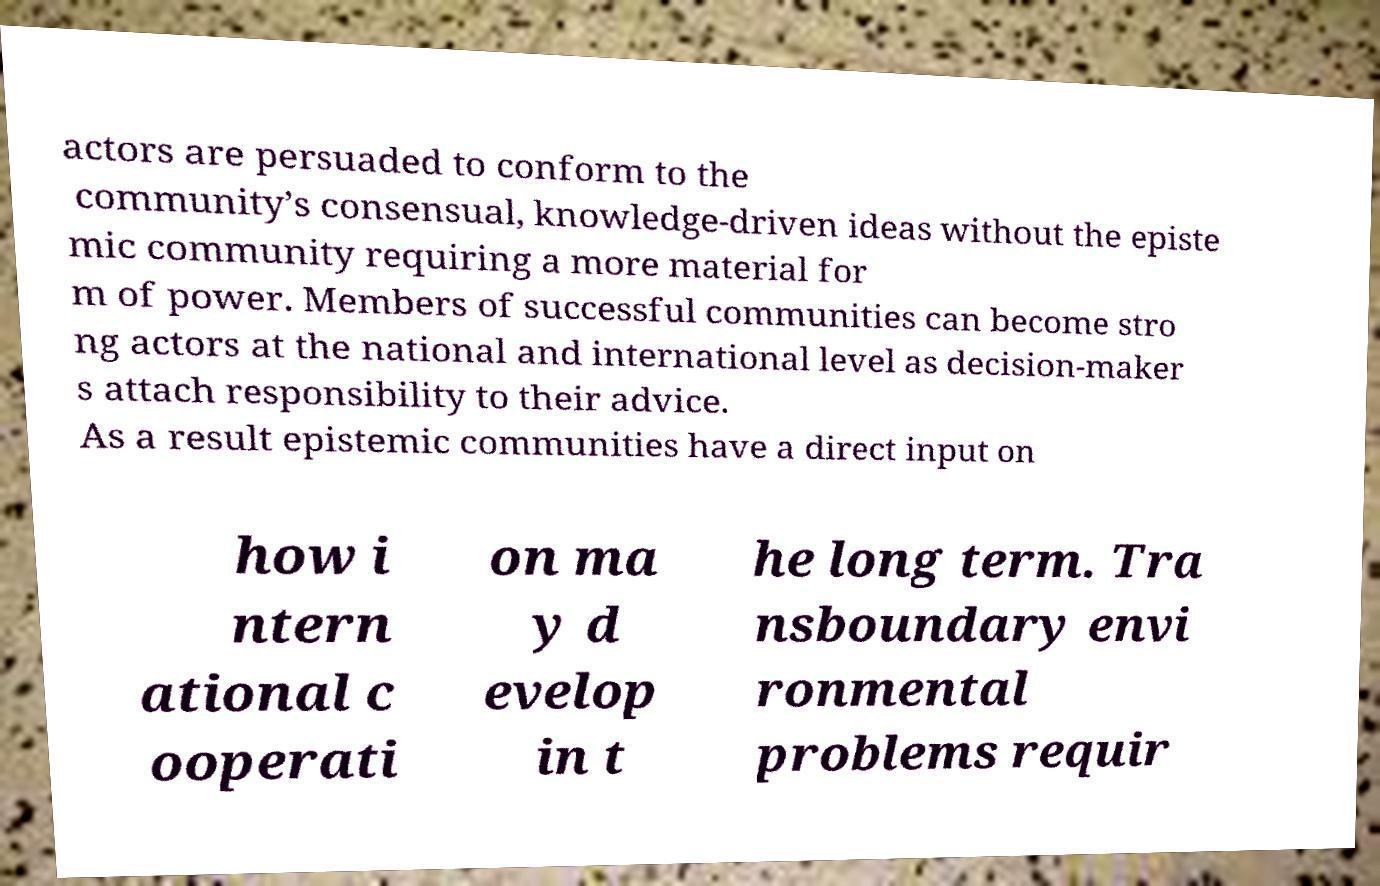What messages or text are displayed in this image? I need them in a readable, typed format. actors are persuaded to conform to the community’s consensual, knowledge-driven ideas without the episte mic community requiring a more material for m of power. Members of successful communities can become stro ng actors at the national and international level as decision-maker s attach responsibility to their advice. As a result epistemic communities have a direct input on how i ntern ational c ooperati on ma y d evelop in t he long term. Tra nsboundary envi ronmental problems requir 